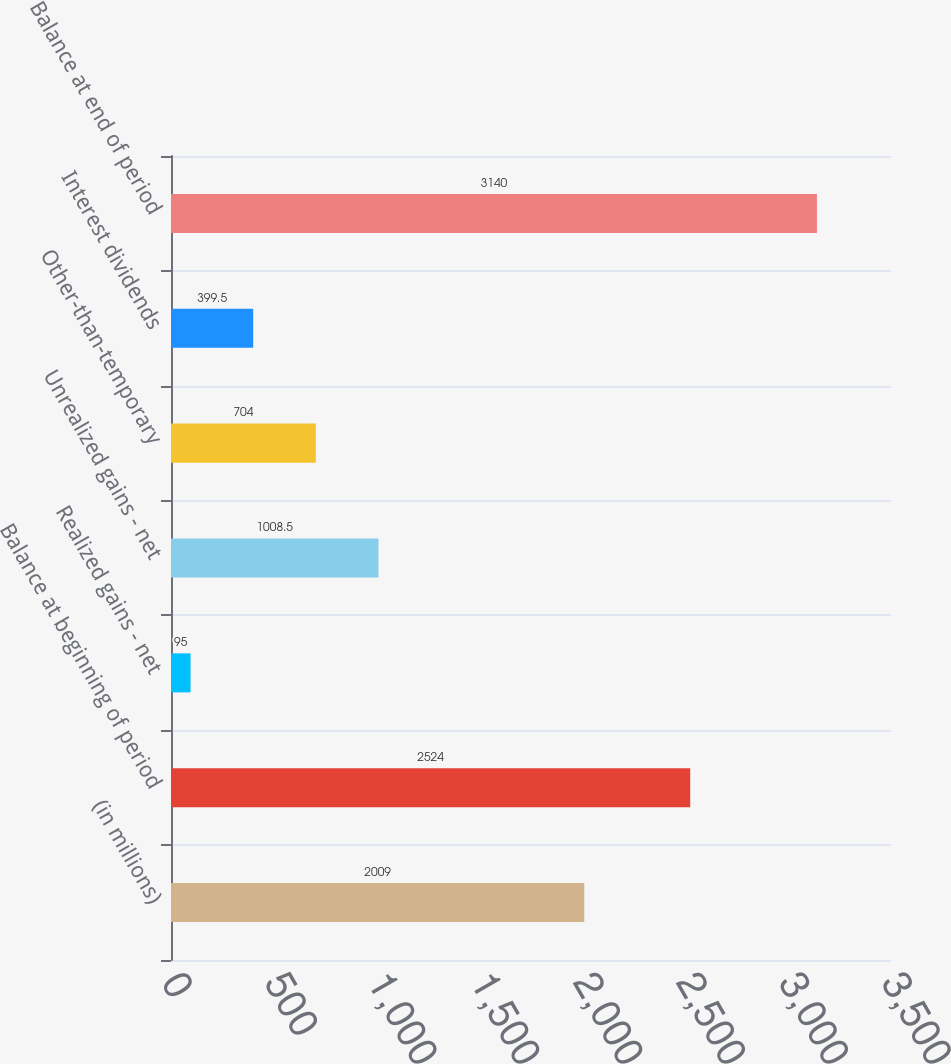Convert chart to OTSL. <chart><loc_0><loc_0><loc_500><loc_500><bar_chart><fcel>(in millions)<fcel>Balance at beginning of period<fcel>Realized gains - net<fcel>Unrealized gains - net<fcel>Other-than-temporary<fcel>Interest dividends<fcel>Balance at end of period<nl><fcel>2009<fcel>2524<fcel>95<fcel>1008.5<fcel>704<fcel>399.5<fcel>3140<nl></chart> 